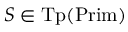Convert formula to latex. <formula><loc_0><loc_0><loc_500><loc_500>S \in { T p } ( { P r i m } )</formula> 